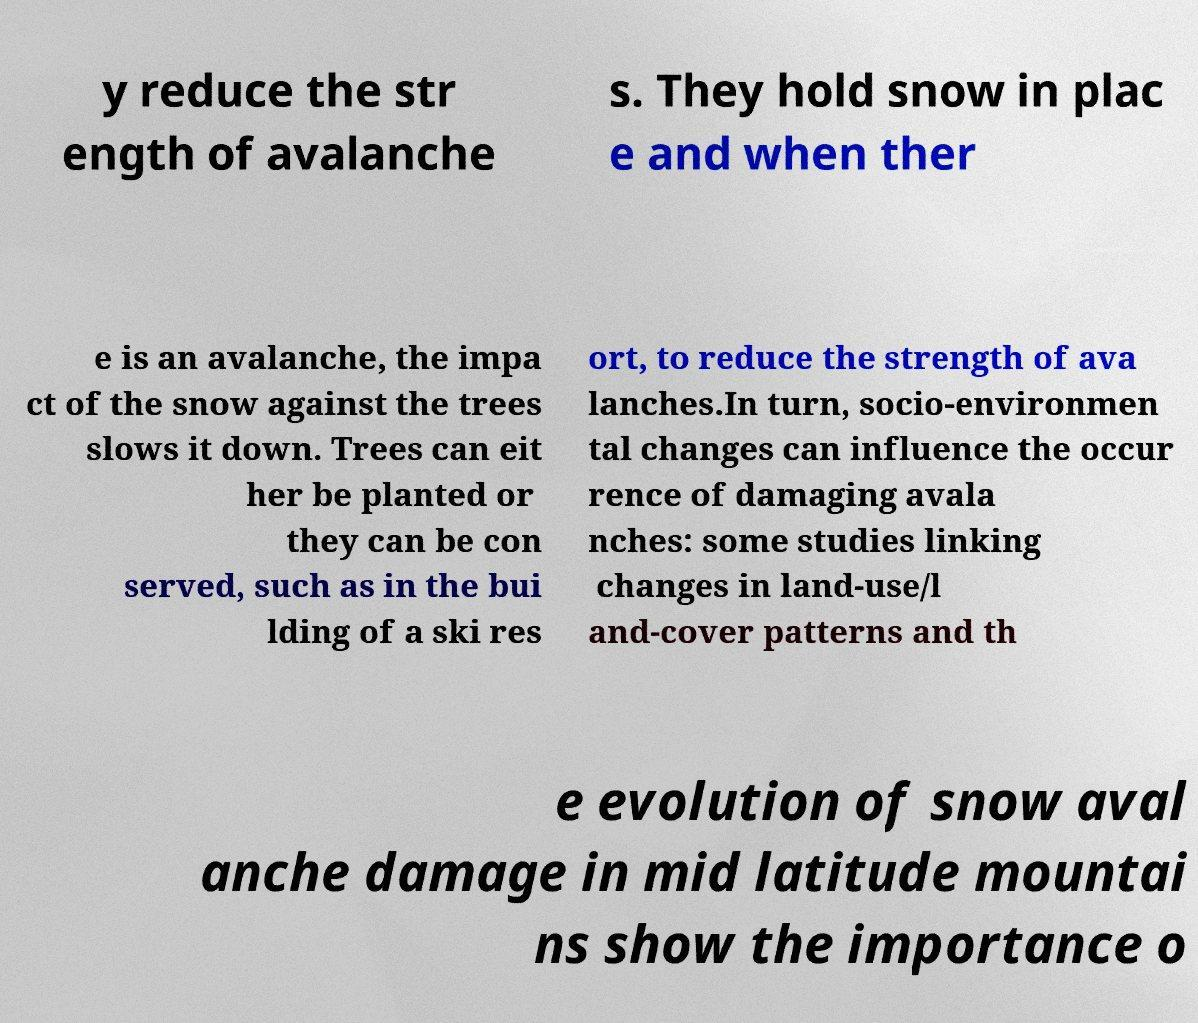Please identify and transcribe the text found in this image. y reduce the str ength of avalanche s. They hold snow in plac e and when ther e is an avalanche, the impa ct of the snow against the trees slows it down. Trees can eit her be planted or they can be con served, such as in the bui lding of a ski res ort, to reduce the strength of ava lanches.In turn, socio-environmen tal changes can influence the occur rence of damaging avala nches: some studies linking changes in land-use/l and-cover patterns and th e evolution of snow aval anche damage in mid latitude mountai ns show the importance o 